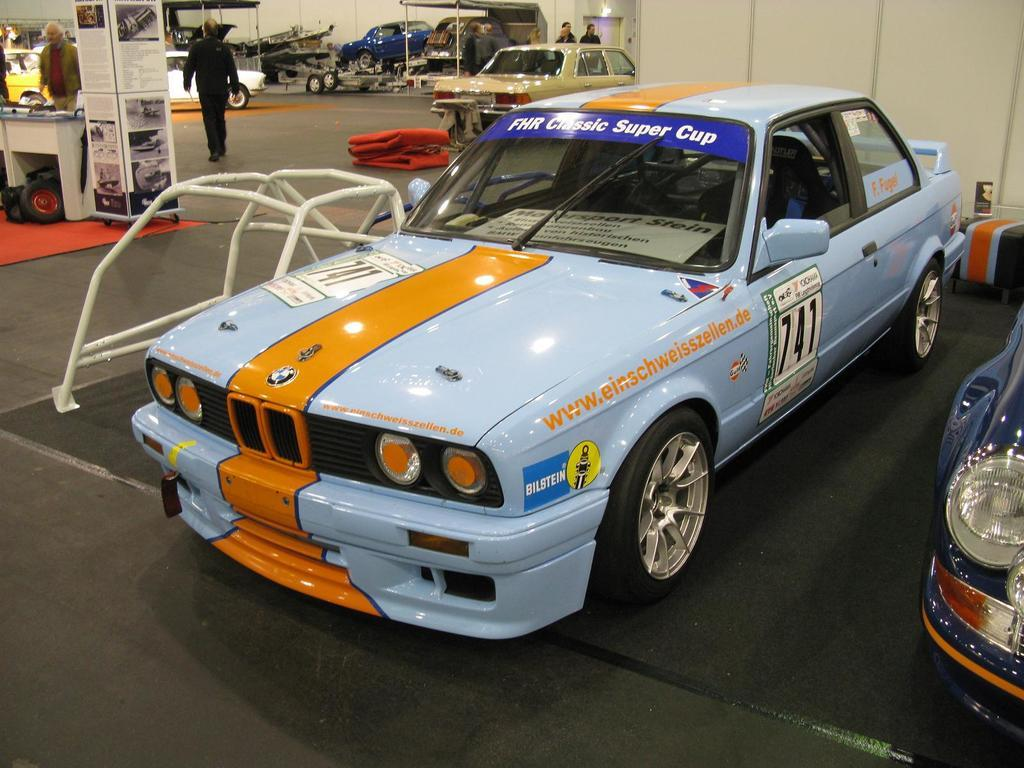What type of vehicles can be seen in the image? There are cars in the image. Can you describe the actions of any individuals in the image? There is a person walking in the image. What type of tray is being used by the person walking in the image? There is no tray present in the image; the person is simply walking. What kind of guide is assisting the person walking in the image? There is no guide present in the image; the person is walking independently. 